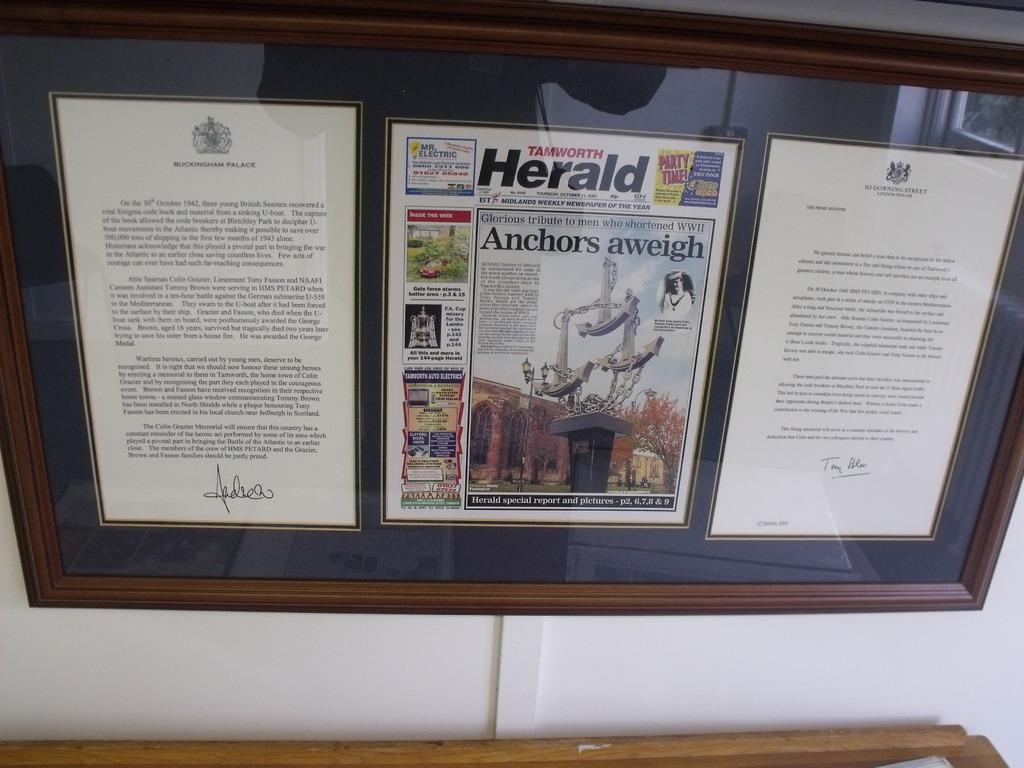Are there any good stories in the local paper?
Offer a very short reply. Unanswerable. What is the name of the newspaper?
Your response must be concise. Herald. 